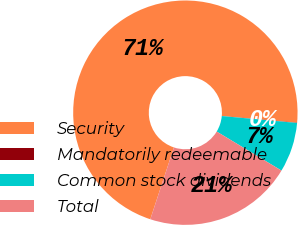<chart> <loc_0><loc_0><loc_500><loc_500><pie_chart><fcel>Security<fcel>Mandatorily redeemable<fcel>Common stock dividends<fcel>Total<nl><fcel>71.36%<fcel>0.04%<fcel>7.17%<fcel>21.43%<nl></chart> 